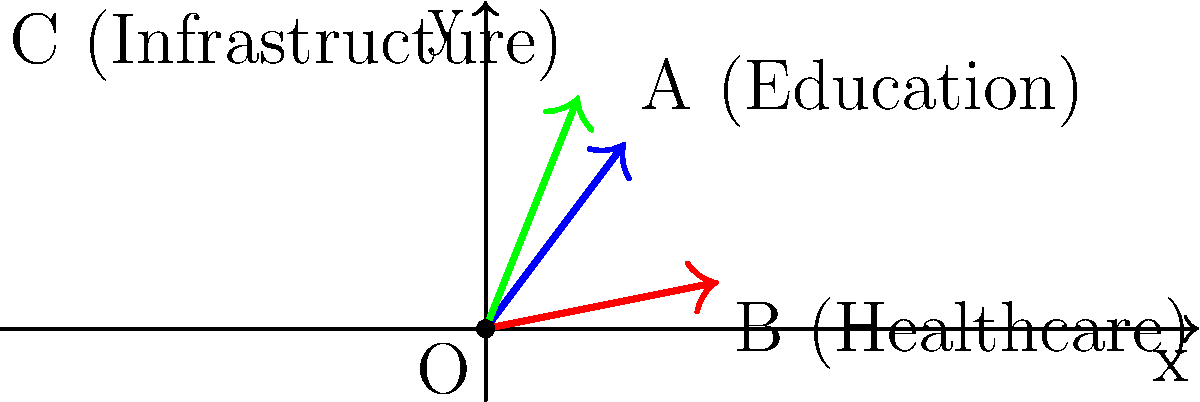In the vector diagram above, three policy impacts are represented: Education (A), Healthcare (B), and Infrastructure (C). Which policy has the greatest magnitude of impact, and by how much does it exceed the policy with the least impact? To determine the policy with the greatest impact and compare magnitudes, we need to calculate the magnitude of each vector:

1. Education (A): 
   $\text{Magnitude} = \sqrt{3^2 + 4^2} = \sqrt{9 + 16} = \sqrt{25} = 5$

2. Healthcare (B):
   $\text{Magnitude} = \sqrt{5^2 + 1^2} = \sqrt{25 + 1} = \sqrt{26} \approx 5.10$

3. Infrastructure (C):
   $\text{Magnitude} = \sqrt{2^2 + 5^2} = \sqrt{4 + 25} = \sqrt{29} \approx 5.39$

Infrastructure (C) has the greatest magnitude at approximately 5.39.
Education (A) has the least magnitude at 5.

The difference between the greatest and least impact:
$5.39 - 5 = 0.39$

Therefore, Infrastructure (C) has the greatest impact, exceeding Education (A) by approximately 0.39 units.
Answer: Infrastructure, by 0.39 units. 